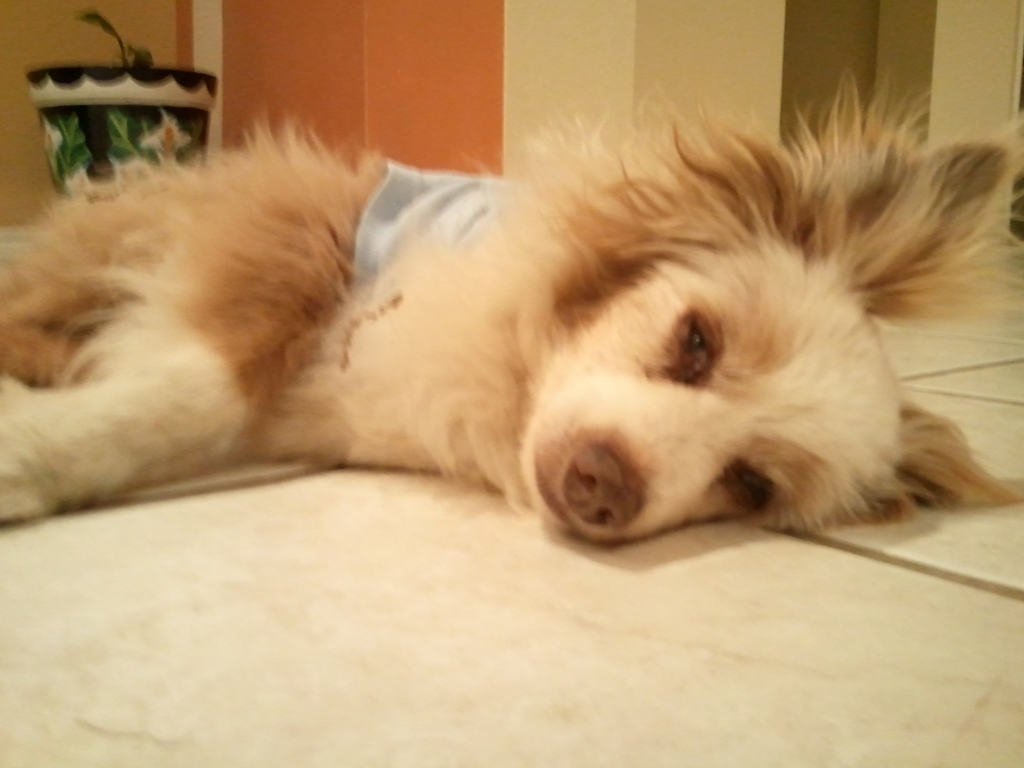Describe the mood of the image and how the elements contribute to it. The mood of the image is one of tranquility and comfort. The dog's serene expression, soft fur, and the calming blue shade of its garment combine to create a peaceful atmosphere. The homely setting with its neutral-colored tiles adds to this sense of quiet domesticity. What story could this image tell? This image might tell the story of a beloved pet enjoying a moment of rest after a day of play or companionship. It highlights the bond between pets and their owners, encapsulating the trust and contentment a pet feels in their home environment. 